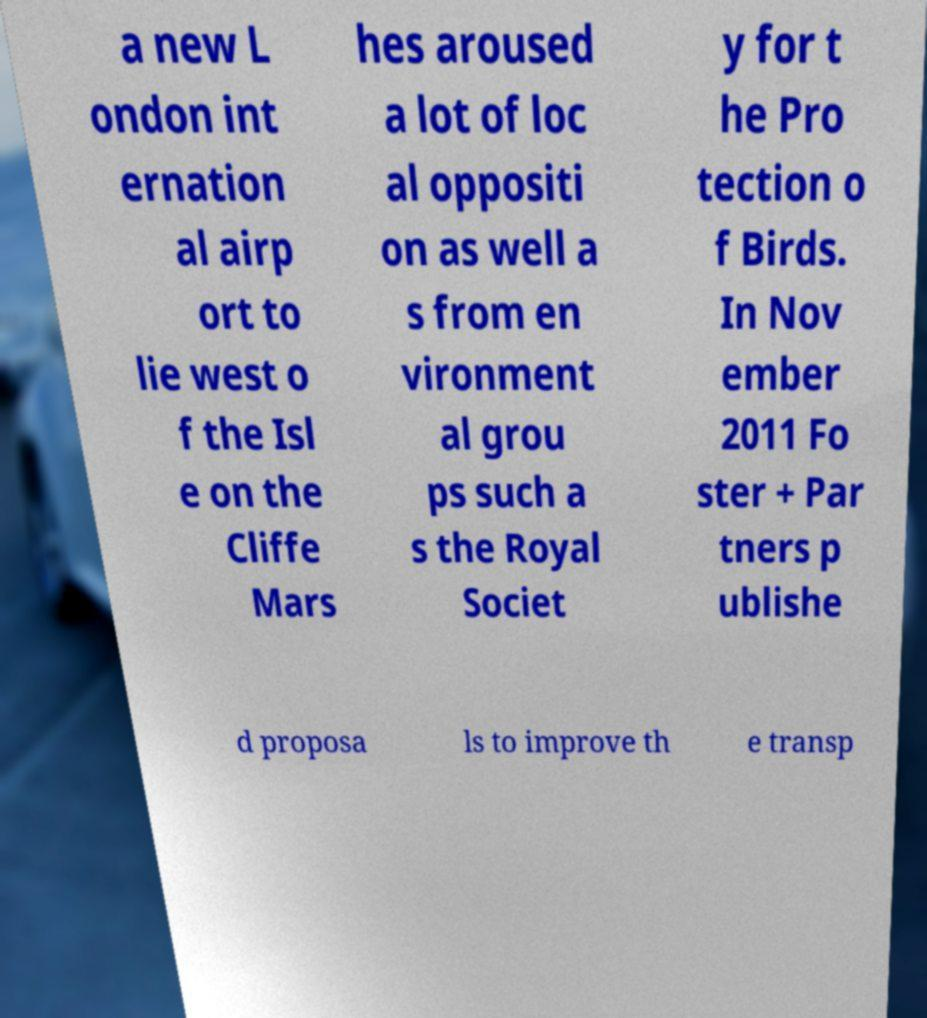I need the written content from this picture converted into text. Can you do that? a new L ondon int ernation al airp ort to lie west o f the Isl e on the Cliffe Mars hes aroused a lot of loc al oppositi on as well a s from en vironment al grou ps such a s the Royal Societ y for t he Pro tection o f Birds. In Nov ember 2011 Fo ster + Par tners p ublishe d proposa ls to improve th e transp 